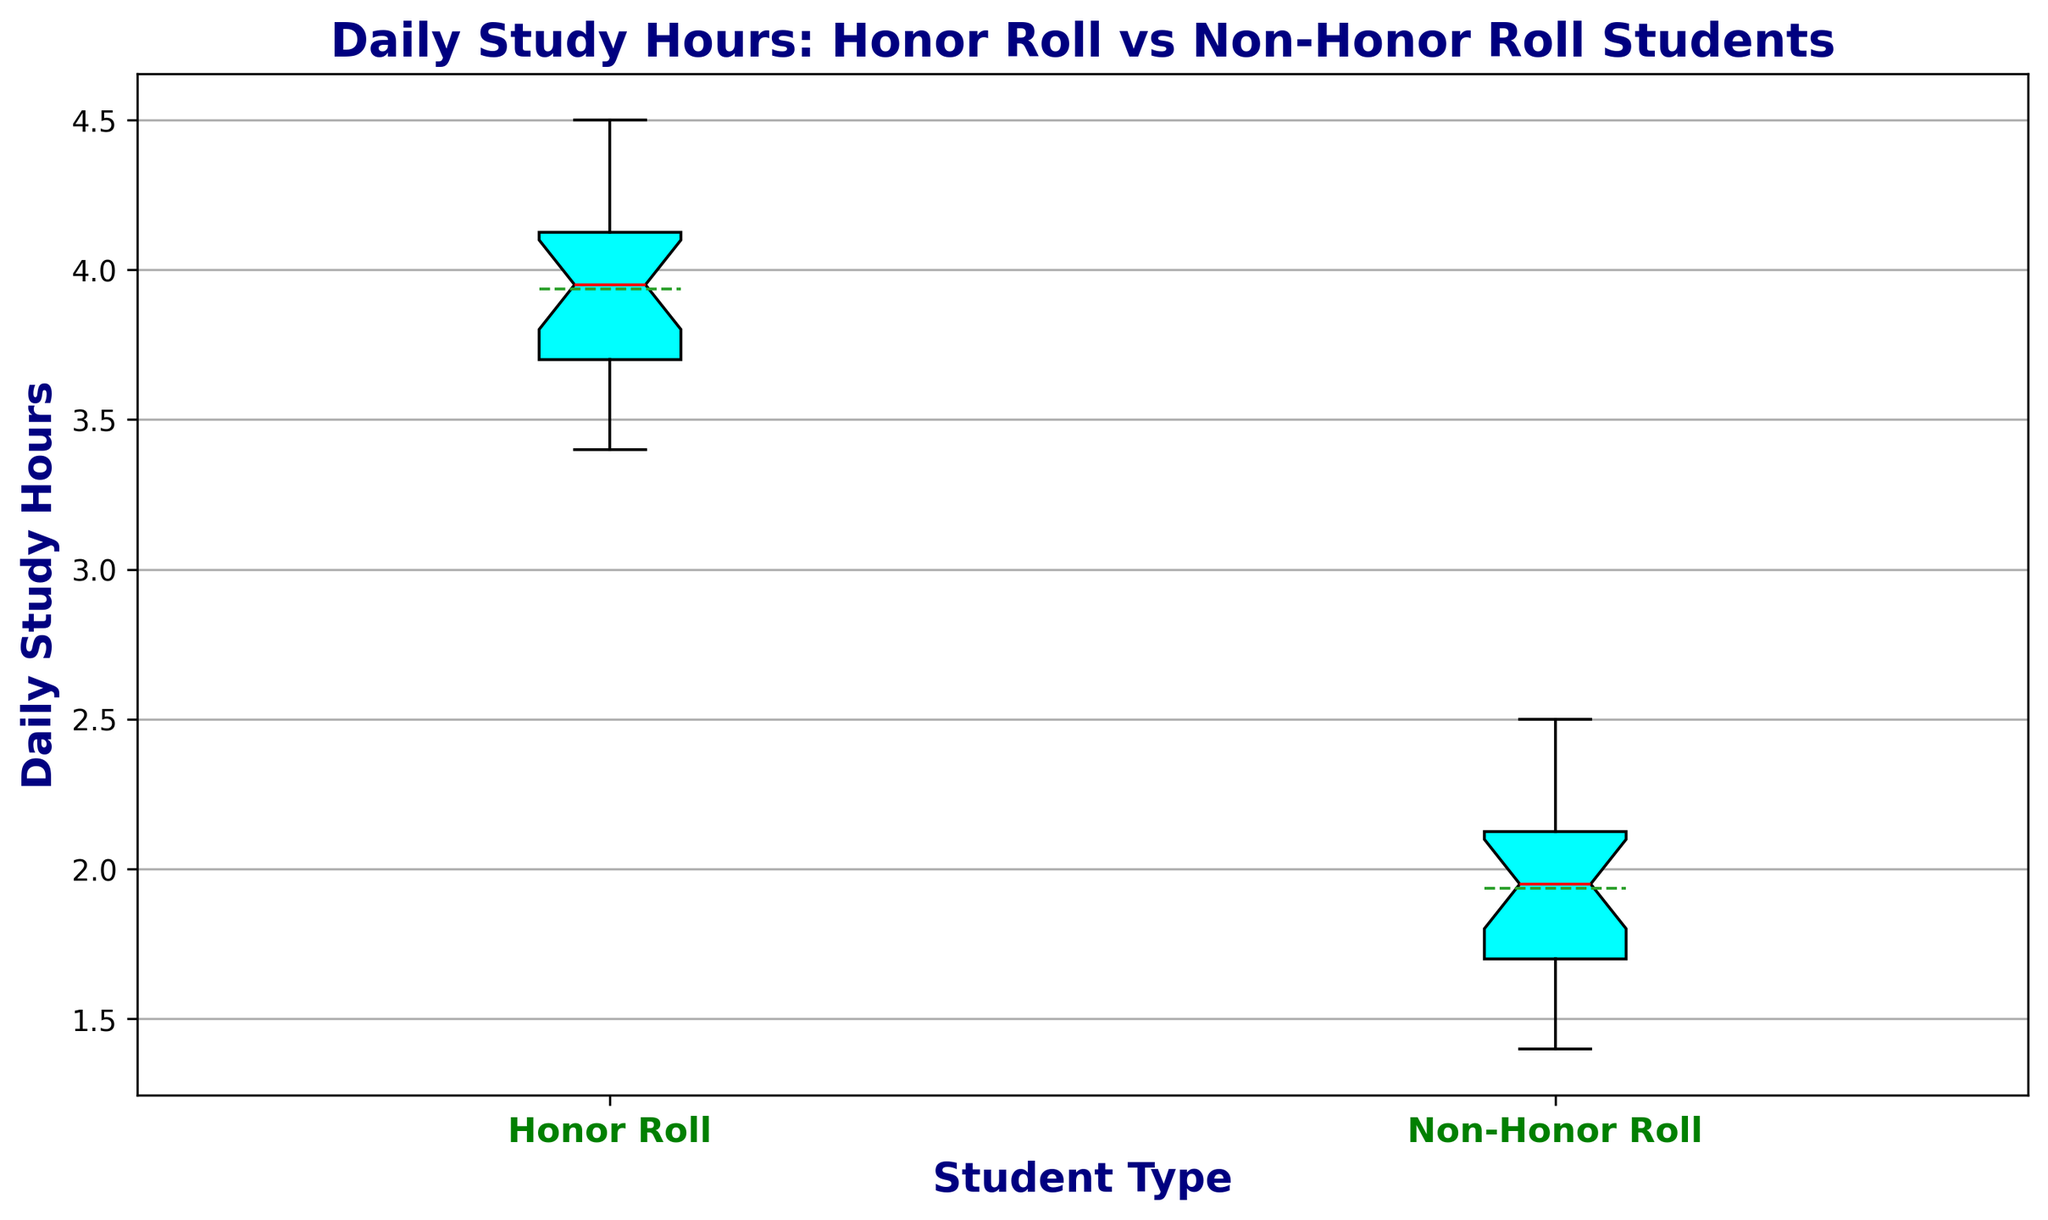Which group has the higher median daily study hours? By looking at the visual attribute of the box plot, we observe that the median line (red) in the box for honor roll students is higher than that of non-honor roll students.
Answer: Honor Roll students What is the mean daily study hours for non-honor roll students? The mean daily study hours is represented by a dashed line inside the box plot. For non-honor roll students, this line is slightly above the median but still within the box.
Answer: Slightly above 2 hours Do honor roll students have a wider range of daily study hours compared to non-honor roll students? The range for each group can be determined by the distance between the bottom and top whiskers. Honor roll students have a smaller range compared to non-honor roll students, meaning non-honor roll students actually have a wider range.
Answer: No What's the interquartile range (IQR) for daily study hours of honor roll students? IQR is the difference between the third quartile (top of the box) and the first quartile (bottom of the box). Visually, you can estimate this by observing the height of the box.
Answer: Approximately 0.6 Which group shows greater variation in daily study hours? Variation can be judged by looking at the overall spread of the data. Non-honor roll students have a wider range from the bottom whisker to top whisker compared to honor roll students.
Answer: Non-Honor Roll students What are the upper and lower whiskers for honor roll students? The upper whisker is the maximum value, and the lower whisker is the minimum value within the range excluding outliers. By looking at the plot, you can spot the endpoints of the vertical lines extending from the box.
Answer: About 4.5 and 3.4 Are there any outliers in the non-honor roll student group? Outliers are usually represented by individual points outside the whiskers in a box plot. Here, there are no points plotted outside the whiskers for non-honor roll students.
Answer: No How do the medians of the two groups compare? The median is represented by the central line inside each box. By directly comparing the position of these lines within the respective boxes, you can see that the honor roll students have a higher median.
Answer: Honor roll’s median is higher What's the difference in mean daily study hours between honor roll and non-honor roll students? The mean is represented by the dashed line inside each box plot. By comparing the positions of these lines, you can estimate the difference.
Answer: About 2 hours 